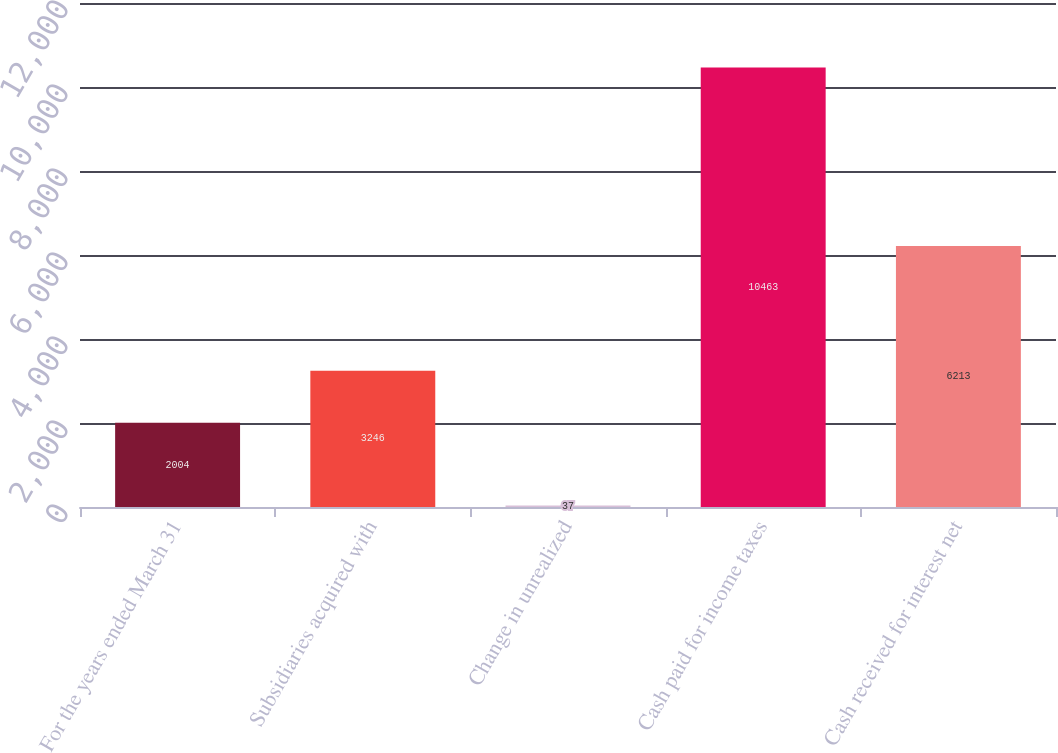Convert chart to OTSL. <chart><loc_0><loc_0><loc_500><loc_500><bar_chart><fcel>For the years ended March 31<fcel>Subsidiaries acquired with<fcel>Change in unrealized<fcel>Cash paid for income taxes<fcel>Cash received for interest net<nl><fcel>2004<fcel>3246<fcel>37<fcel>10463<fcel>6213<nl></chart> 